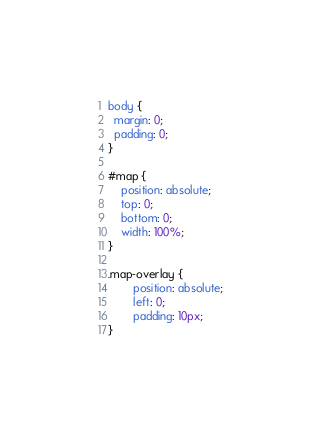<code> <loc_0><loc_0><loc_500><loc_500><_CSS_>body {
  margin: 0;
  padding: 0;
}

#map {
	position: absolute;
	top: 0;
	bottom: 0;
	width: 100%;
}

.map-overlay {
		position: absolute;
		left: 0;
		padding: 10px;
}		
</code> 